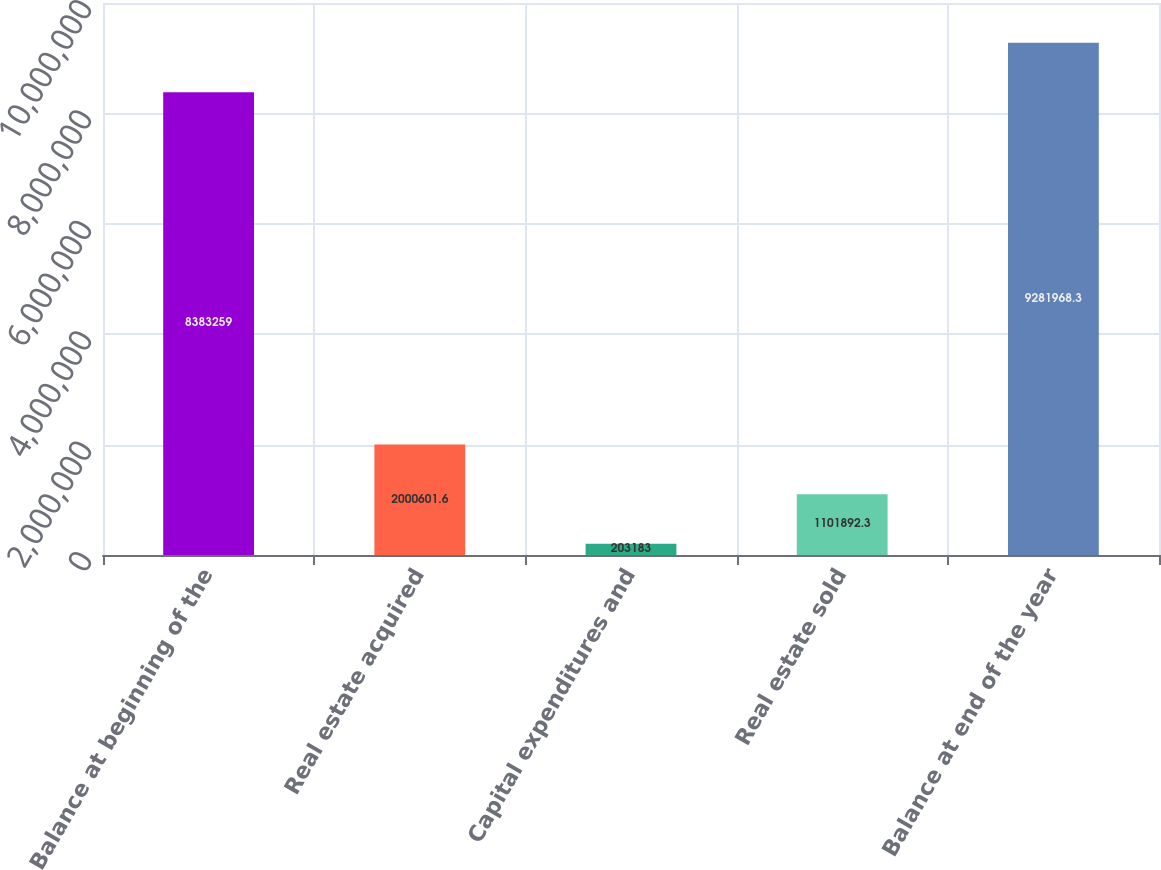<chart> <loc_0><loc_0><loc_500><loc_500><bar_chart><fcel>Balance at beginning of the<fcel>Real estate acquired<fcel>Capital expenditures and<fcel>Real estate sold<fcel>Balance at end of the year<nl><fcel>8.38326e+06<fcel>2.0006e+06<fcel>203183<fcel>1.10189e+06<fcel>9.28197e+06<nl></chart> 